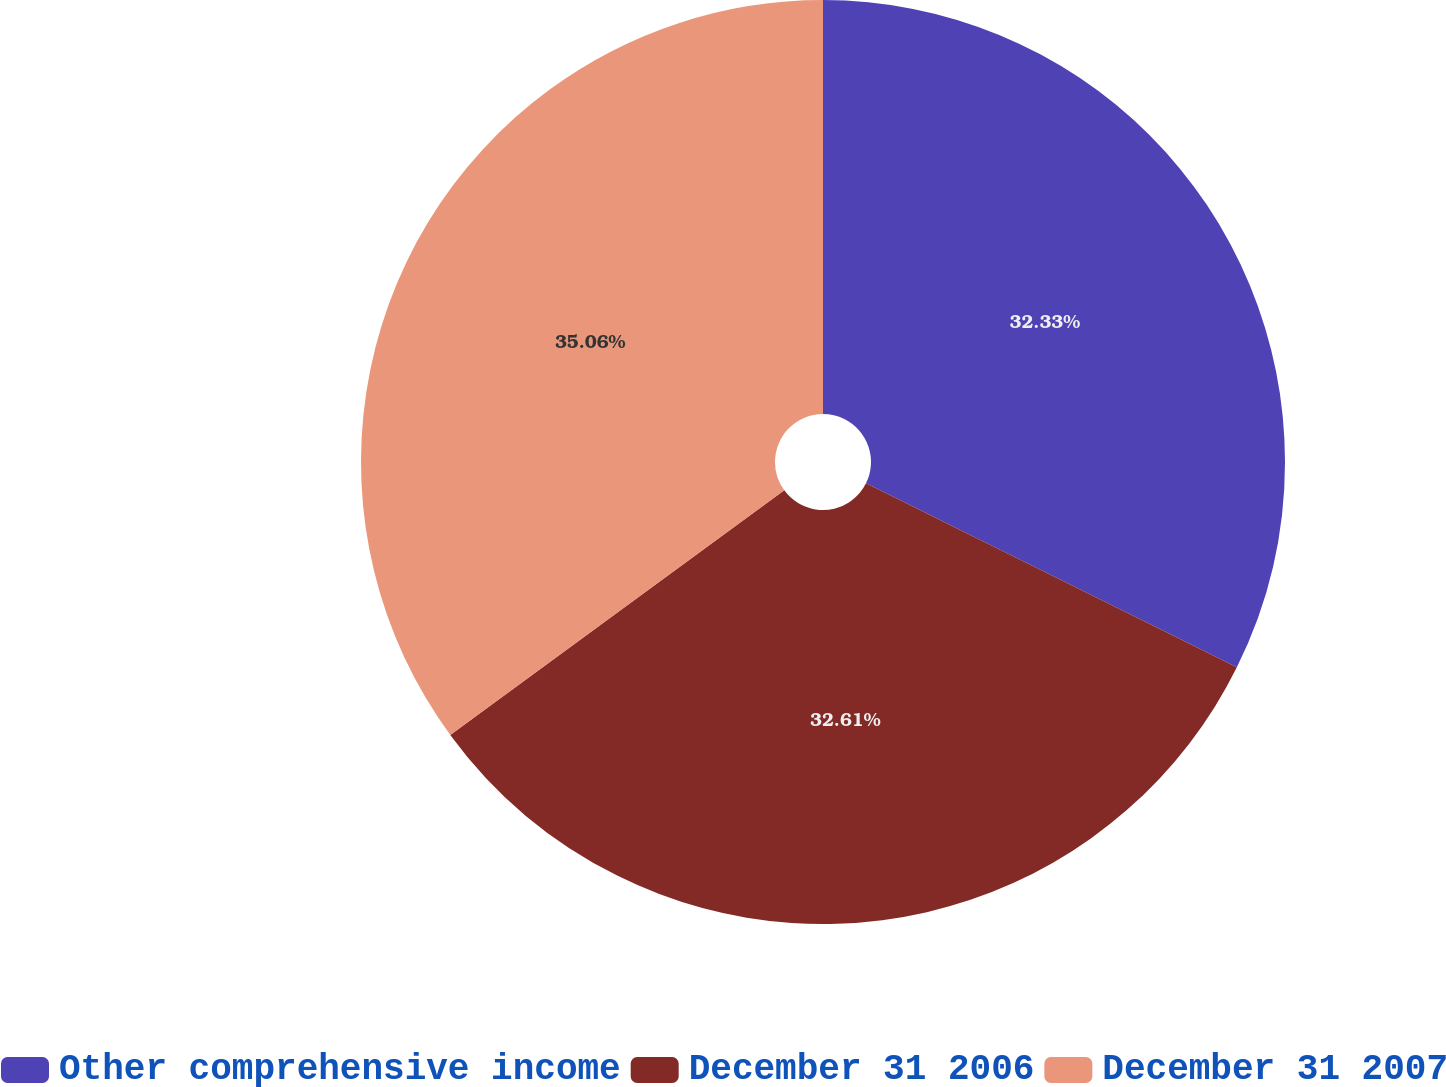<chart> <loc_0><loc_0><loc_500><loc_500><pie_chart><fcel>Other comprehensive income<fcel>December 31 2006<fcel>December 31 2007<nl><fcel>32.33%<fcel>32.61%<fcel>35.06%<nl></chart> 